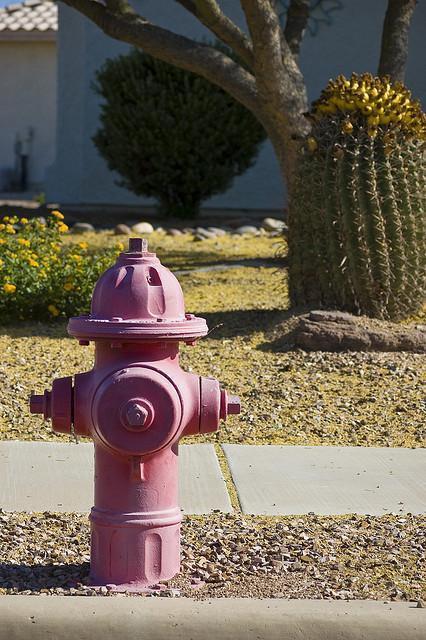How many potted plants are there?
Give a very brief answer. 2. 